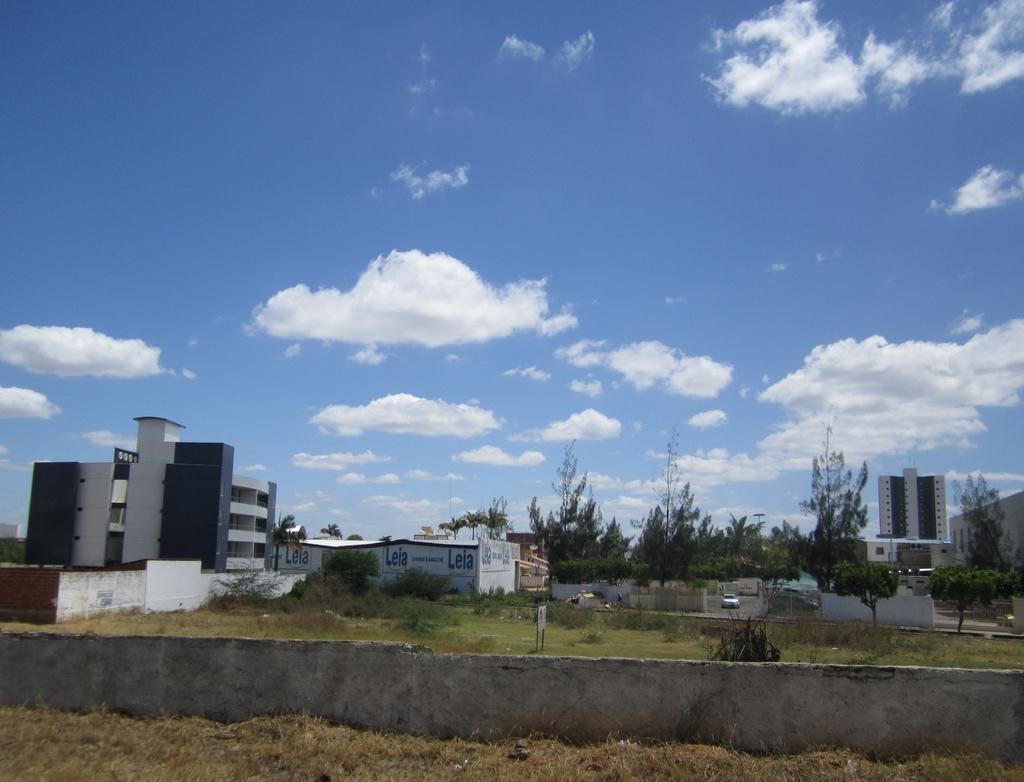Describe this image in one or two sentences. In the image we can see there are buildings and trees. Here we can see wall, grass, plant, board and a cloudy pale blue sky. We can even see a vehicle on the road. 